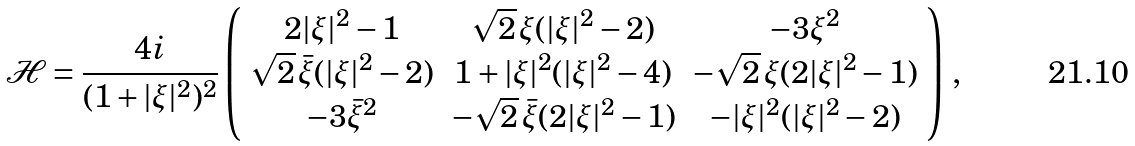<formula> <loc_0><loc_0><loc_500><loc_500>\mathcal { H } = \frac { 4 i } { ( 1 + | \xi | ^ { 2 } ) ^ { 2 } } \left ( \begin{array} { c c c } 2 | \xi | ^ { 2 } - 1 & \sqrt { 2 } \, \xi ( | \xi | ^ { 2 } - 2 ) & - 3 \xi ^ { 2 } \\ \sqrt { 2 } \, \bar { \xi } ( | \xi | ^ { 2 } - 2 ) & 1 + | \xi | ^ { 2 } ( | \xi | ^ { 2 } - 4 ) & - \sqrt { 2 } \, \xi ( 2 | \xi | ^ { 2 } - 1 ) \\ - 3 \bar { \xi } ^ { 2 } & - \sqrt { 2 } \, \bar { \xi } ( 2 | \xi | ^ { 2 } - 1 ) & - | \xi | ^ { 2 } ( | \xi | ^ { 2 } - 2 ) \end{array} \right ) \, ,</formula> 